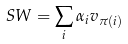Convert formula to latex. <formula><loc_0><loc_0><loc_500><loc_500>S W = \sum _ { i } \alpha _ { i } v _ { \pi ( i ) }</formula> 